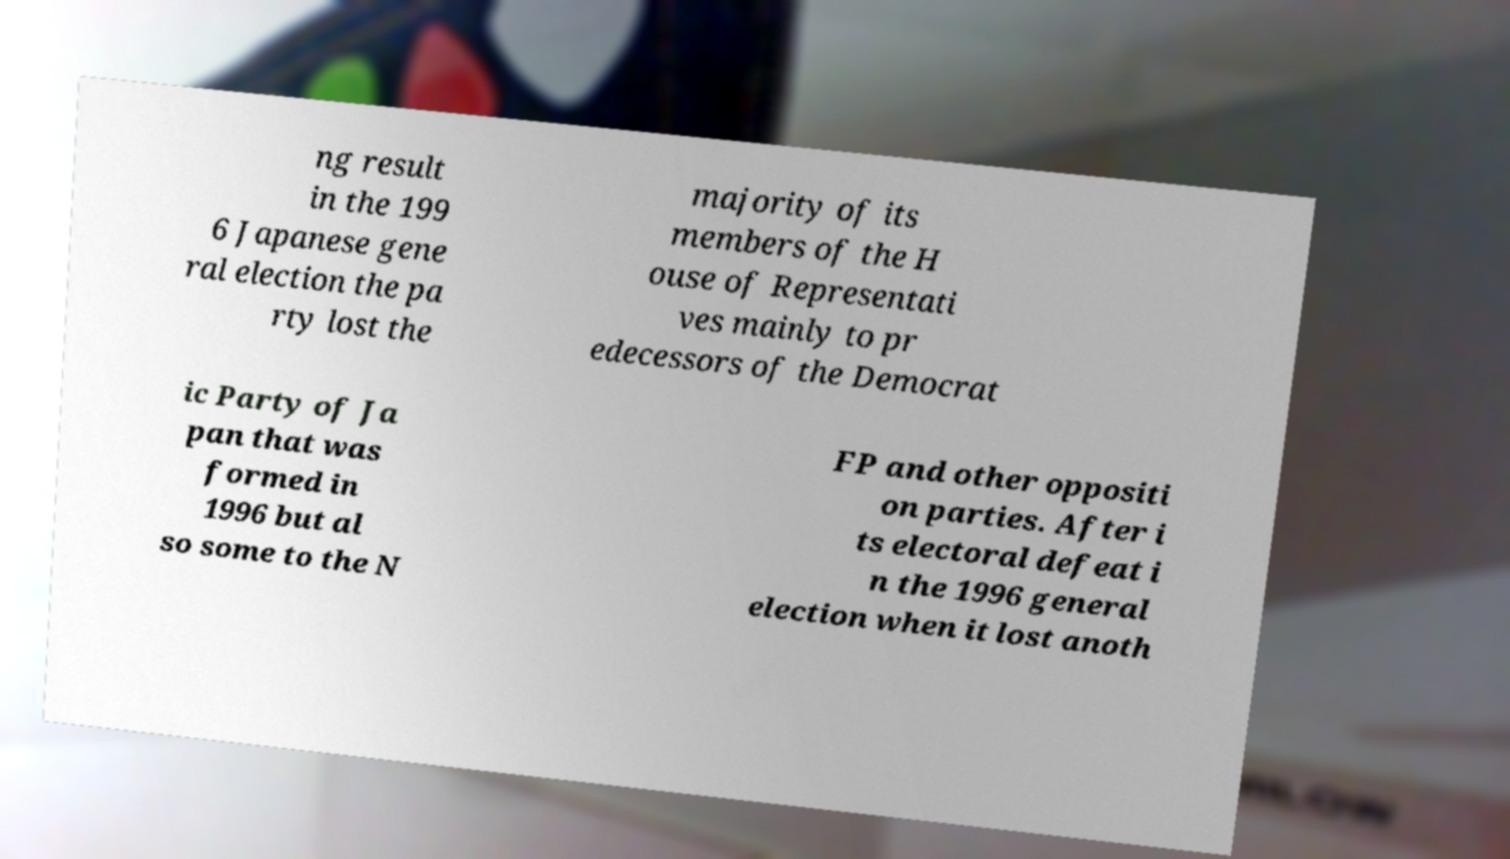There's text embedded in this image that I need extracted. Can you transcribe it verbatim? ng result in the 199 6 Japanese gene ral election the pa rty lost the majority of its members of the H ouse of Representati ves mainly to pr edecessors of the Democrat ic Party of Ja pan that was formed in 1996 but al so some to the N FP and other oppositi on parties. After i ts electoral defeat i n the 1996 general election when it lost anoth 